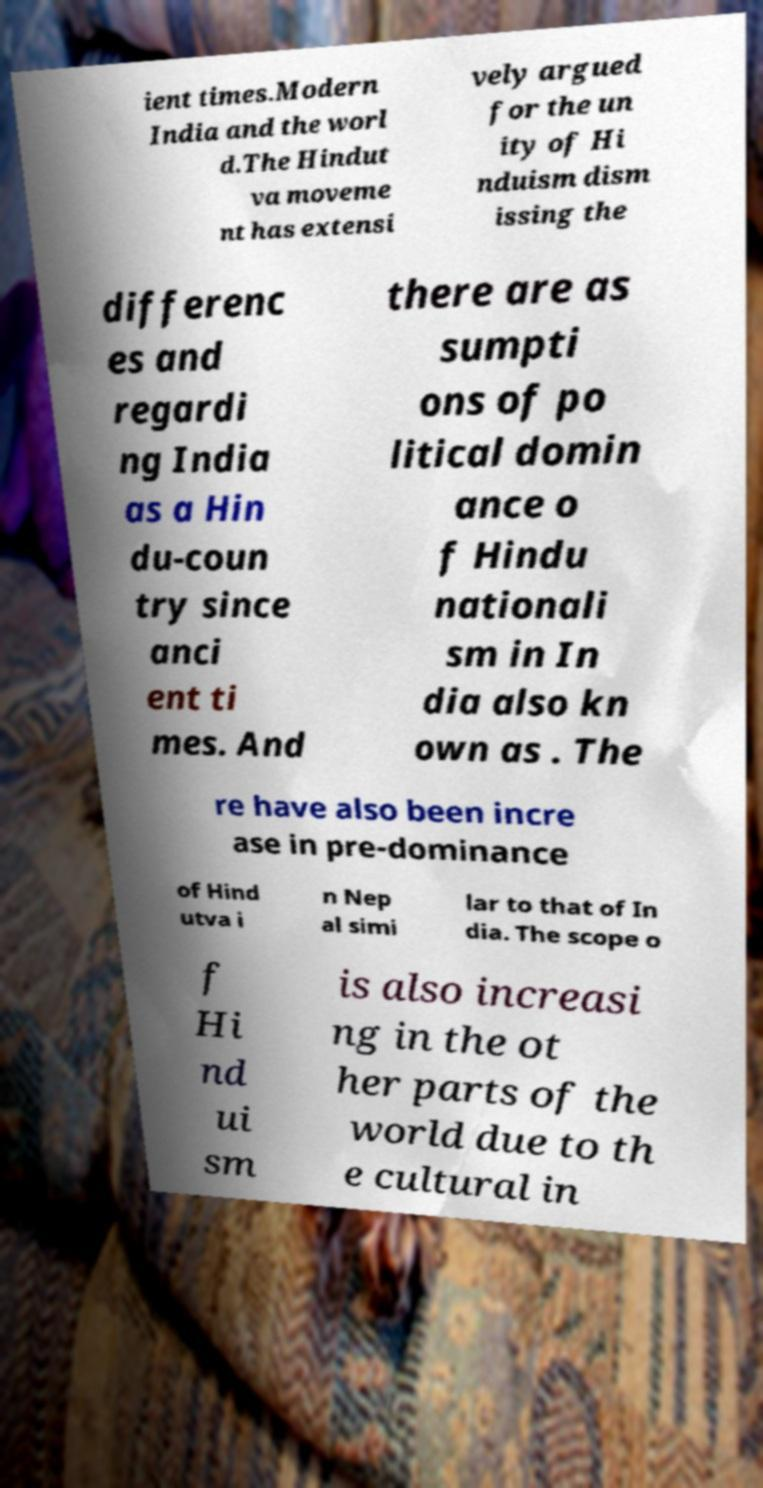Could you extract and type out the text from this image? ient times.Modern India and the worl d.The Hindut va moveme nt has extensi vely argued for the un ity of Hi nduism dism issing the differenc es and regardi ng India as a Hin du-coun try since anci ent ti mes. And there are as sumpti ons of po litical domin ance o f Hindu nationali sm in In dia also kn own as . The re have also been incre ase in pre-dominance of Hind utva i n Nep al simi lar to that of In dia. The scope o f Hi nd ui sm is also increasi ng in the ot her parts of the world due to th e cultural in 